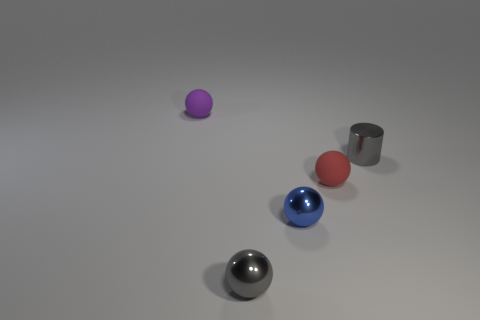Subtract all green balls. Subtract all brown cylinders. How many balls are left? 4 Add 1 large purple shiny cylinders. How many objects exist? 6 Subtract all spheres. How many objects are left? 1 Subtract 0 cyan cylinders. How many objects are left? 5 Subtract all blue shiny objects. Subtract all matte objects. How many objects are left? 2 Add 1 tiny matte balls. How many tiny matte balls are left? 3 Add 1 tiny blue metal balls. How many tiny blue metal balls exist? 2 